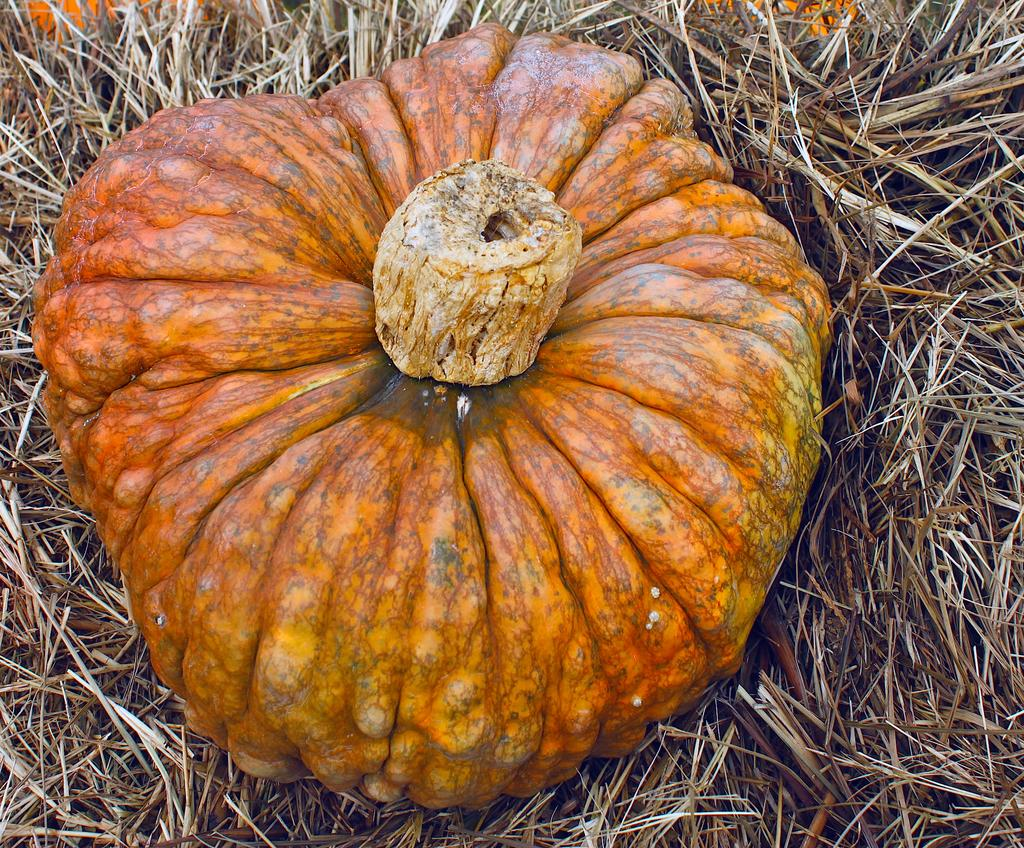What is the main object in the image? There is a pumpkin in the image. What is the surface on which the pumpkin is placed? The pumpkin is on dry grass. Where is the harbor located in the image? There is no harbor present in the image; it only features a pumpkin on dry grass. 